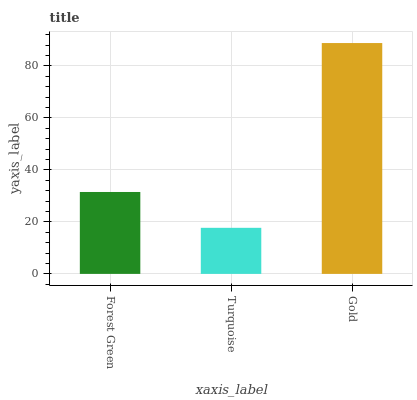Is Gold the maximum?
Answer yes or no. Yes. Is Gold the minimum?
Answer yes or no. No. Is Turquoise the maximum?
Answer yes or no. No. Is Gold greater than Turquoise?
Answer yes or no. Yes. Is Turquoise less than Gold?
Answer yes or no. Yes. Is Turquoise greater than Gold?
Answer yes or no. No. Is Gold less than Turquoise?
Answer yes or no. No. Is Forest Green the high median?
Answer yes or no. Yes. Is Forest Green the low median?
Answer yes or no. Yes. Is Gold the high median?
Answer yes or no. No. Is Gold the low median?
Answer yes or no. No. 